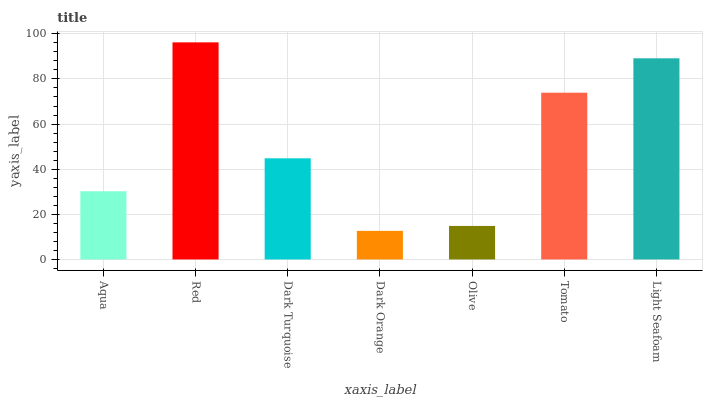Is Dark Turquoise the minimum?
Answer yes or no. No. Is Dark Turquoise the maximum?
Answer yes or no. No. Is Red greater than Dark Turquoise?
Answer yes or no. Yes. Is Dark Turquoise less than Red?
Answer yes or no. Yes. Is Dark Turquoise greater than Red?
Answer yes or no. No. Is Red less than Dark Turquoise?
Answer yes or no. No. Is Dark Turquoise the high median?
Answer yes or no. Yes. Is Dark Turquoise the low median?
Answer yes or no. Yes. Is Olive the high median?
Answer yes or no. No. Is Light Seafoam the low median?
Answer yes or no. No. 